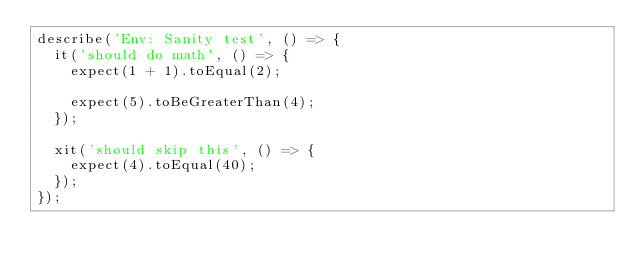<code> <loc_0><loc_0><loc_500><loc_500><_TypeScript_>describe('Env: Sanity test', () => {
  it('should do math', () => {
    expect(1 + 1).toEqual(2);

    expect(5).toBeGreaterThan(4);
  });

  xit('should skip this', () => {
    expect(4).toEqual(40);
  });
});
</code> 